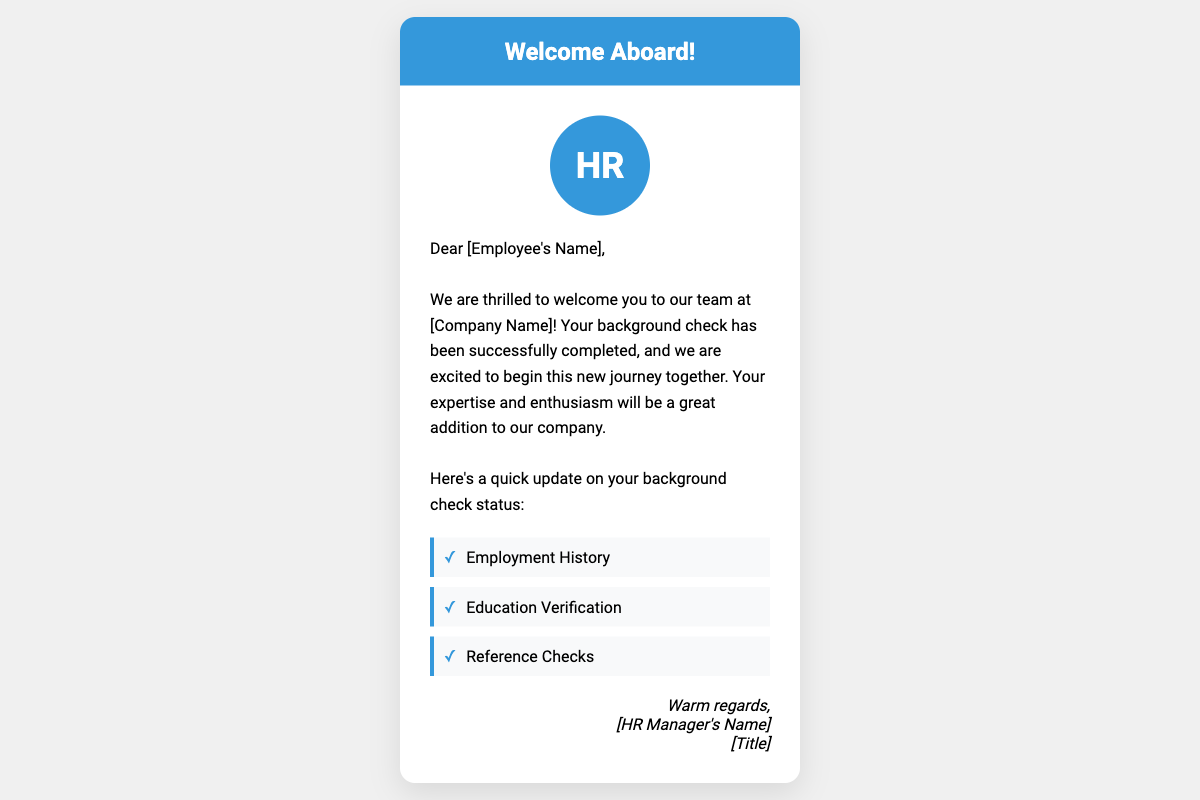What is the card's main purpose? The card is designed to welcome a new employee and inform them that their background check has been completed.
Answer: Welcome Aboard Who is the card addressed to? The card is directed at the new employee, with a placeholder for their name.
Answer: [Employee's Name] What color is the card's header? The header background color is a specific shade mentioned within the document.
Answer: Blue How many milestones are listed in the background check status update? The document includes a specific number of milestones that relate to the background check process.
Answer: Three Who signed the card? The closing signature of the card includes a placeholder for the HR manager's name and title.
Answer: [HR Manager's Name] What is the main theme of the card design? The design elements of the card showcase a specific style that aligns with the company's branding and purpose.
Answer: Modern What positive message is conveyed in the card? The card includes a statement about the excitement of the new employee joining the team.
Answer: Thrilled What elements of design are used to symbolize the background check status? The design incorporates specific features that depict progress in the background check process.
Answer: Checkmarks What feature emphasizes the professional nature of the card? The use of a particular design element throughout the card contributes to its overall professional appearance.
Answer: Elegant 